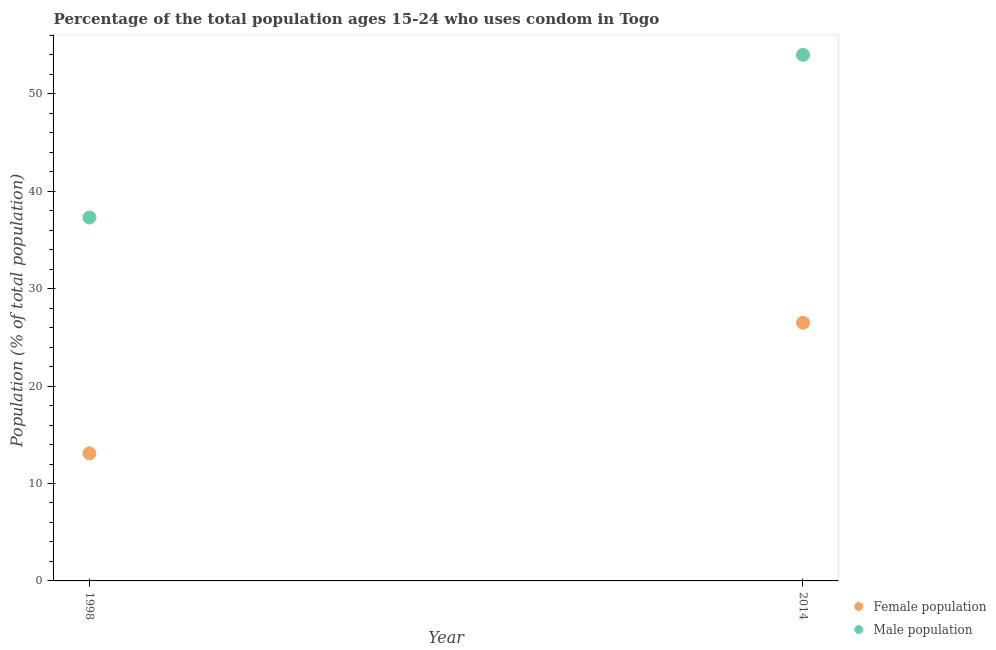How many different coloured dotlines are there?
Offer a very short reply. 2. What is the male population in 1998?
Provide a succinct answer. 37.3. Across all years, what is the maximum male population?
Provide a succinct answer. 54. In which year was the female population maximum?
Make the answer very short. 2014. What is the total male population in the graph?
Offer a very short reply. 91.3. What is the difference between the male population in 1998 and that in 2014?
Offer a terse response. -16.7. What is the difference between the male population in 2014 and the female population in 1998?
Offer a very short reply. 40.9. What is the average male population per year?
Your response must be concise. 45.65. In the year 1998, what is the difference between the male population and female population?
Keep it short and to the point. 24.2. In how many years, is the female population greater than 48 %?
Ensure brevity in your answer.  0. What is the ratio of the female population in 1998 to that in 2014?
Your answer should be very brief. 0.49. Is the female population in 1998 less than that in 2014?
Your response must be concise. Yes. In how many years, is the female population greater than the average female population taken over all years?
Make the answer very short. 1. Does the female population monotonically increase over the years?
Keep it short and to the point. Yes. Is the female population strictly greater than the male population over the years?
Offer a very short reply. No. Are the values on the major ticks of Y-axis written in scientific E-notation?
Provide a succinct answer. No. Where does the legend appear in the graph?
Provide a succinct answer. Bottom right. How are the legend labels stacked?
Give a very brief answer. Vertical. What is the title of the graph?
Offer a very short reply. Percentage of the total population ages 15-24 who uses condom in Togo. Does "Banks" appear as one of the legend labels in the graph?
Your answer should be very brief. No. What is the label or title of the Y-axis?
Offer a terse response. Population (% of total population) . What is the Population (% of total population)  in Male population in 1998?
Keep it short and to the point. 37.3. Across all years, what is the maximum Population (% of total population)  of Male population?
Keep it short and to the point. 54. Across all years, what is the minimum Population (% of total population)  of Female population?
Provide a short and direct response. 13.1. Across all years, what is the minimum Population (% of total population)  in Male population?
Ensure brevity in your answer.  37.3. What is the total Population (% of total population)  in Female population in the graph?
Provide a short and direct response. 39.6. What is the total Population (% of total population)  of Male population in the graph?
Make the answer very short. 91.3. What is the difference between the Population (% of total population)  in Male population in 1998 and that in 2014?
Provide a succinct answer. -16.7. What is the difference between the Population (% of total population)  in Female population in 1998 and the Population (% of total population)  in Male population in 2014?
Your response must be concise. -40.9. What is the average Population (% of total population)  in Female population per year?
Your answer should be very brief. 19.8. What is the average Population (% of total population)  of Male population per year?
Keep it short and to the point. 45.65. In the year 1998, what is the difference between the Population (% of total population)  of Female population and Population (% of total population)  of Male population?
Give a very brief answer. -24.2. In the year 2014, what is the difference between the Population (% of total population)  in Female population and Population (% of total population)  in Male population?
Provide a succinct answer. -27.5. What is the ratio of the Population (% of total population)  in Female population in 1998 to that in 2014?
Ensure brevity in your answer.  0.49. What is the ratio of the Population (% of total population)  of Male population in 1998 to that in 2014?
Provide a succinct answer. 0.69. 